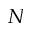Convert formula to latex. <formula><loc_0><loc_0><loc_500><loc_500>N</formula> 